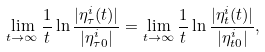Convert formula to latex. <formula><loc_0><loc_0><loc_500><loc_500>\lim _ { t \rightarrow \infty } \frac { 1 } { t } \ln \frac { | \eta ^ { i } _ { \tau } ( t ) | } { | \eta ^ { i } _ { \tau 0 } | } = \lim _ { t \rightarrow \infty } \frac { 1 } { t } \ln \frac { | \eta ^ { i } _ { t } ( t ) | } { | \eta ^ { i } _ { t 0 } | } ,</formula> 